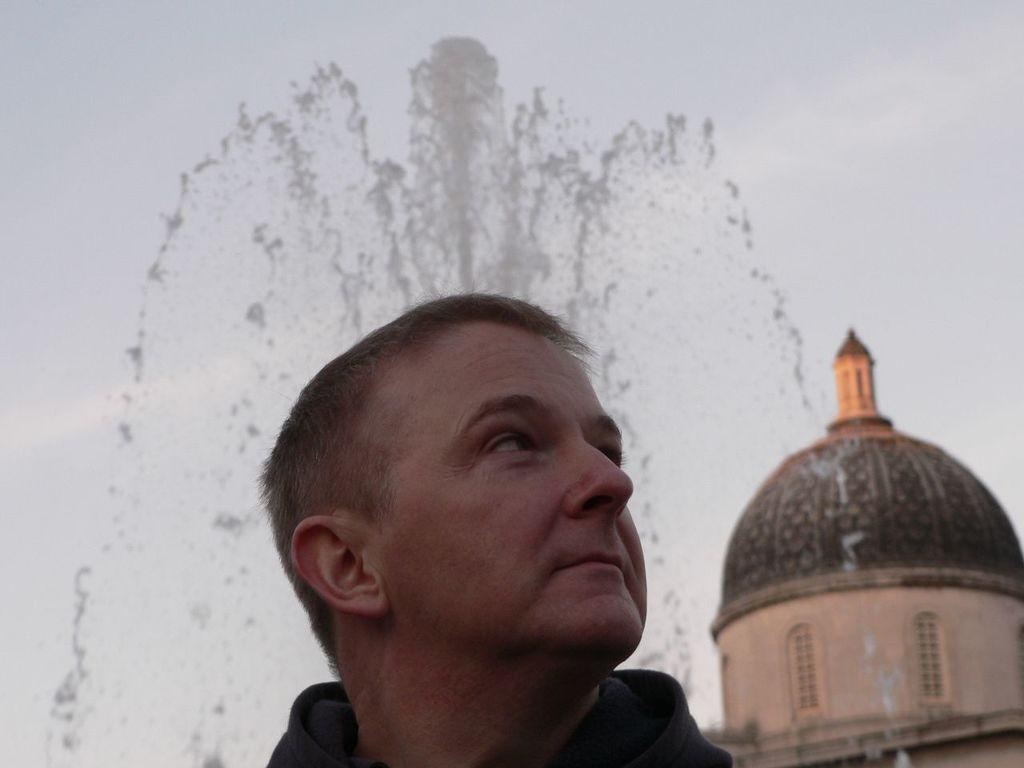What is the main subject of the image? There is a person in the image. What type of structure can be seen in the image? There is a building with a tomb in the image. What can be seen in the background of the image? There is a fountain and the sky visible in the background of the image. What type of cake is being served at the educational event in the image? There is no cake or educational event present in the image. How many trees can be seen in the image? There are no trees visible in the image. 